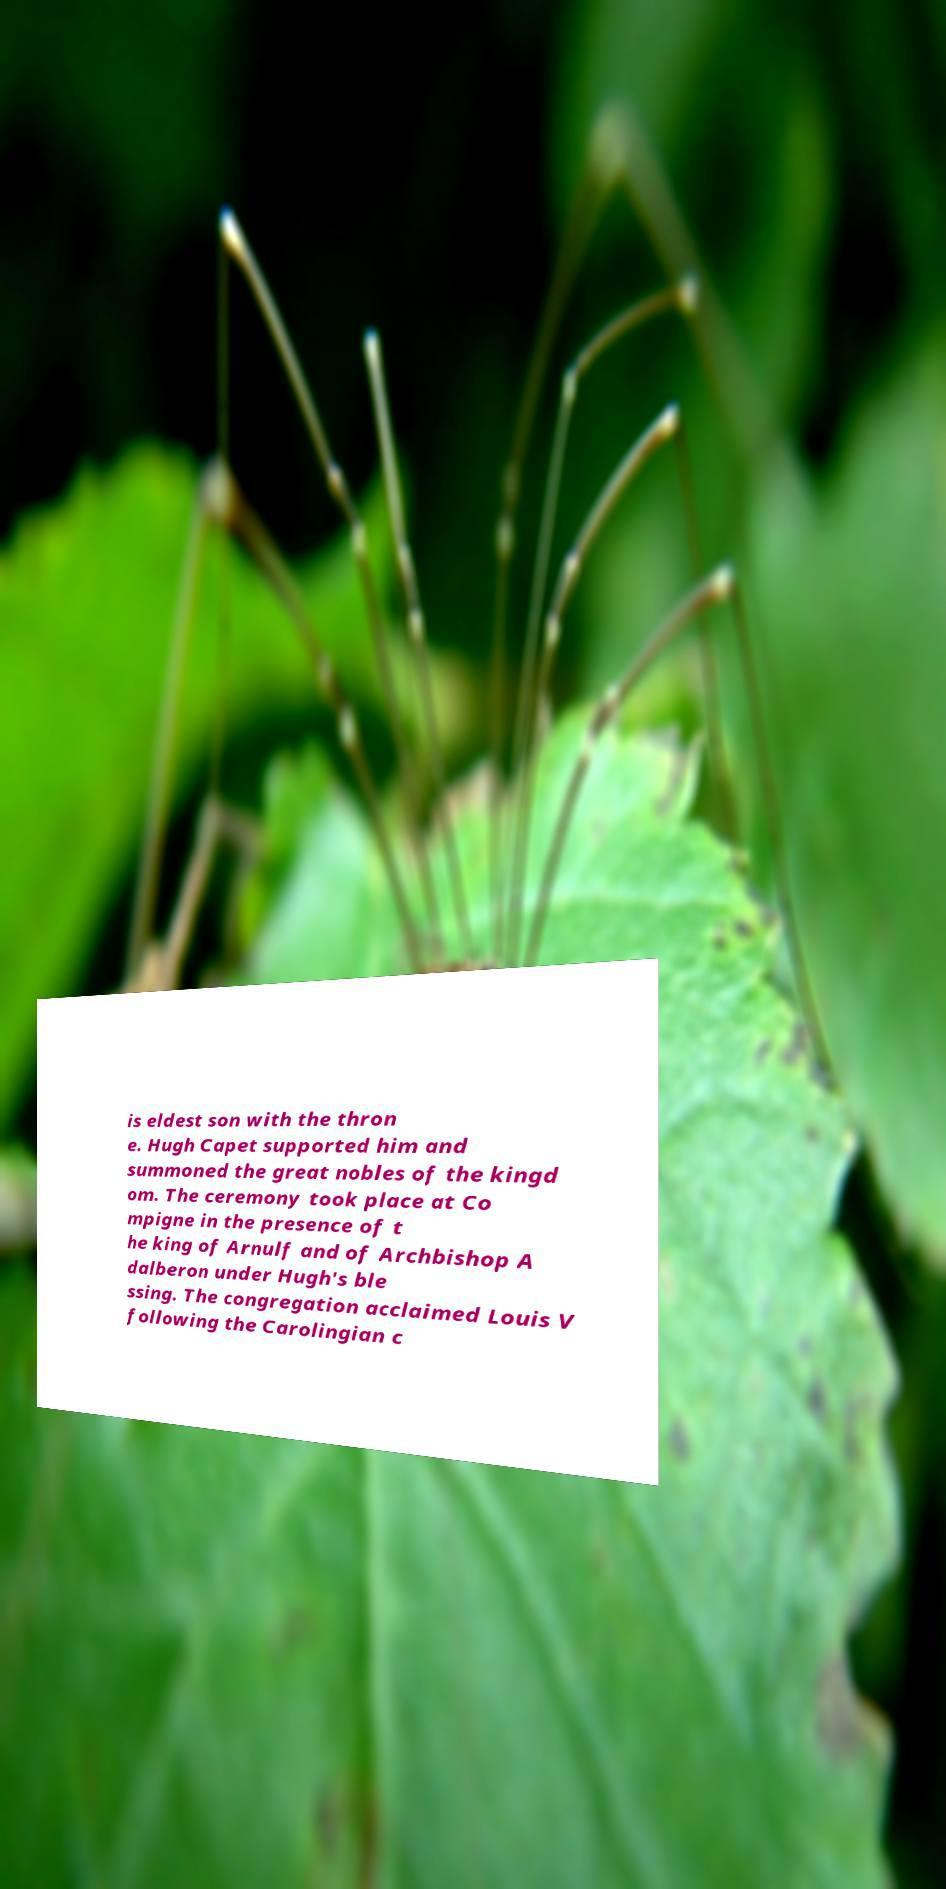Can you read and provide the text displayed in the image?This photo seems to have some interesting text. Can you extract and type it out for me? is eldest son with the thron e. Hugh Capet supported him and summoned the great nobles of the kingd om. The ceremony took place at Co mpigne in the presence of t he king of Arnulf and of Archbishop A dalberon under Hugh's ble ssing. The congregation acclaimed Louis V following the Carolingian c 